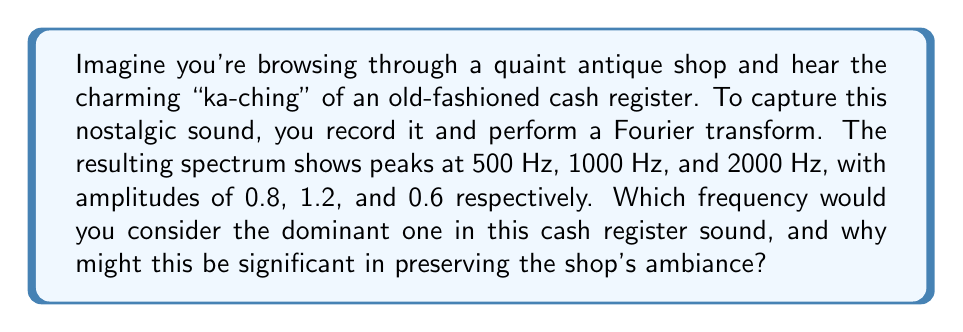Can you solve this math problem? To determine the dominant frequency in the cash register sound, we need to compare the amplitudes of the peaks in the Fourier transform spectrum. The Fourier transform decomposes a signal into its constituent frequencies, and the amplitude of each frequency component represents its contribution to the overall sound.

Given:
- 500 Hz peak with amplitude 0.8
- 1000 Hz peak with amplitude 1.2
- 2000 Hz peak with amplitude 0.6

The dominant frequency is the one with the highest amplitude, as it contributes the most to the overall sound. In this case:

$$\text{Dominant Frequency} = \max(A_{500}, A_{1000}, A_{2000})$$

where $A_f$ represents the amplitude at frequency $f$.

$$\max(0.8, 1.2, 0.6) = 1.2$$

This corresponds to the 1000 Hz peak.

The significance of the 1000 Hz dominant frequency in preserving the shop's ambiance lies in its mid-range nature. This frequency is:
1. High enough to provide clarity and distinctiveness to the "ka-ching" sound.
2. Low enough to maintain a warm, nostalgic quality without being harsh or tinny.

Understanding this dominant frequency could help in:
- Accurately reproducing the sound for historical reenactments or vintage-themed events.
- Designing audio systems that highlight these characteristic frequencies in the shop.
- Creating digital versions of the sound that maintain its authentic feel.
Answer: The dominant frequency is 1000 Hz, with an amplitude of 1.2. 